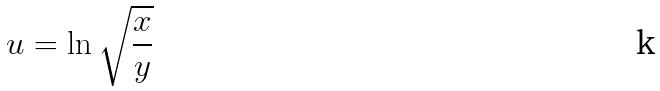Convert formula to latex. <formula><loc_0><loc_0><loc_500><loc_500>u = \ln \sqrt { \frac { x } { y } }</formula> 